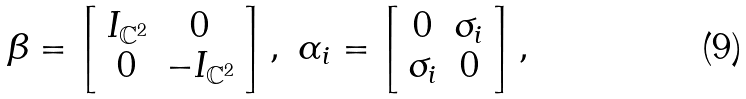Convert formula to latex. <formula><loc_0><loc_0><loc_500><loc_500>\beta = \left [ \begin{array} { c c } I _ { \mathbb { C } ^ { 2 } } & 0 \\ 0 & - I _ { \mathbb { C } ^ { 2 } } \end{array} \right ] , \ \alpha _ { i } = \left [ \begin{array} { c c } 0 & \sigma _ { i } \\ \sigma _ { i } & 0 \end{array} \right ] ,</formula> 